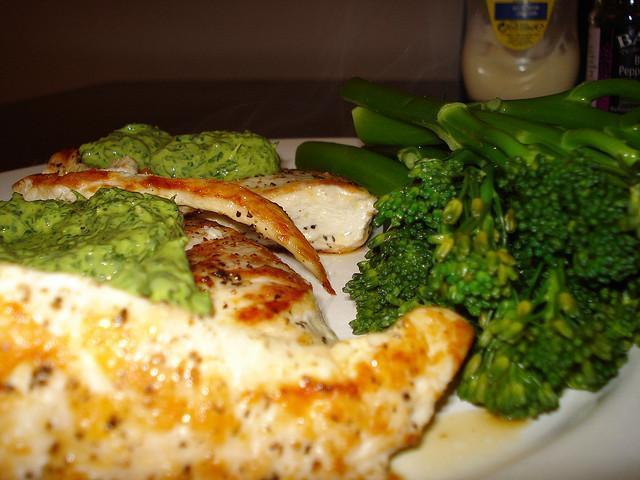How many bottles are there?
Give a very brief answer. 2. 